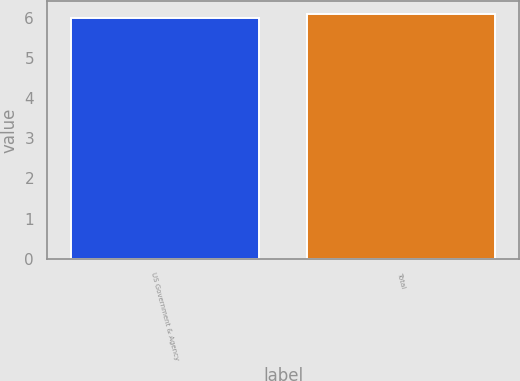Convert chart to OTSL. <chart><loc_0><loc_0><loc_500><loc_500><bar_chart><fcel>US Government & Agency<fcel>Total<nl><fcel>6<fcel>6.1<nl></chart> 